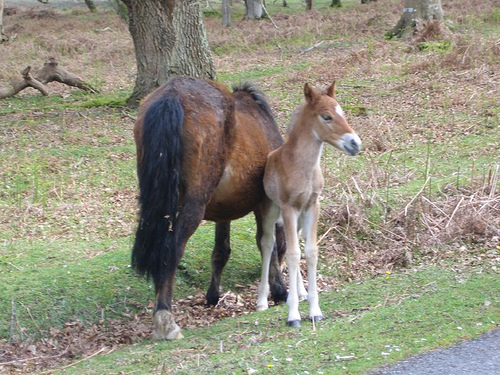<image>What does the smaller horse like to eat? I don't know what the smaller horse likes to eat. It could be grass, hay, or milk. What does the smaller horse like to eat? I am not sure what the smaller horse likes to eat. It can be grass, hay, or milk. 